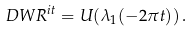Convert formula to latex. <formula><loc_0><loc_0><loc_500><loc_500>\ D W R ^ { i t } = U ( \lambda _ { 1 } ( - 2 \pi t ) ) \, .</formula> 